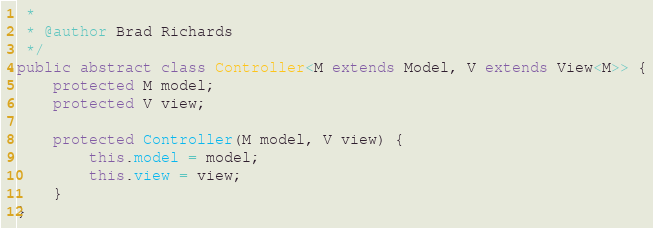<code> <loc_0><loc_0><loc_500><loc_500><_Java_> * 
 * @author Brad Richards
 */
public abstract class Controller<M extends Model, V extends View<M>> {
    protected M model;
    protected V view;
    
    protected Controller(M model, V view) {
        this.model = model;
        this.view = view;
    }
}
</code> 